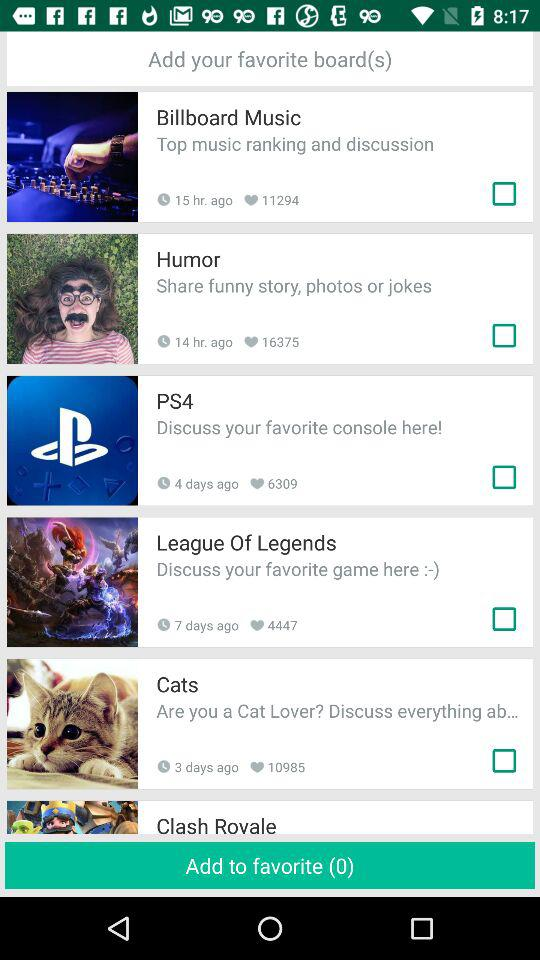How many items are selected for adding to favorites? The number of items that are selected for adding to favorites is 0. 